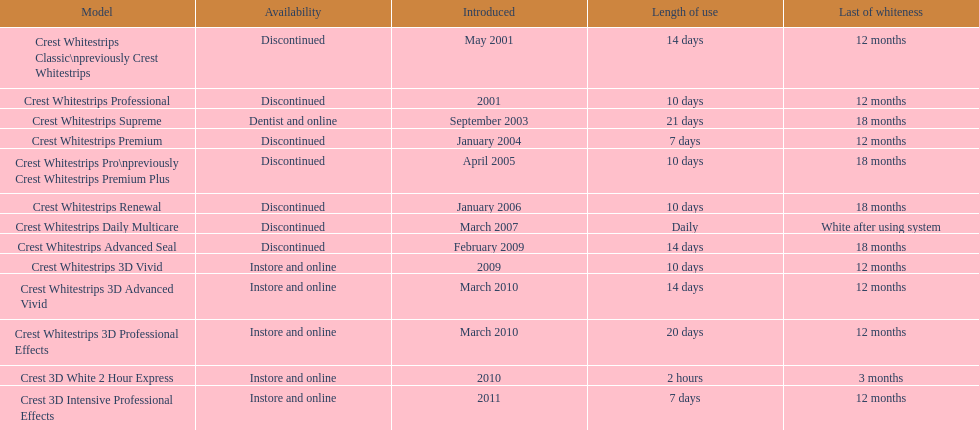Can the crest white strips pro maintain their effectiveness for as long as the crest white strips renewal? Yes. 